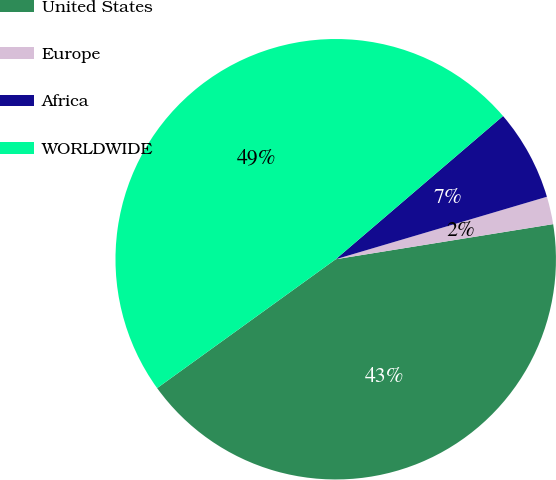Convert chart. <chart><loc_0><loc_0><loc_500><loc_500><pie_chart><fcel>United States<fcel>Europe<fcel>Africa<fcel>WORLDWIDE<nl><fcel>42.6%<fcel>2.03%<fcel>6.69%<fcel>48.68%<nl></chart> 